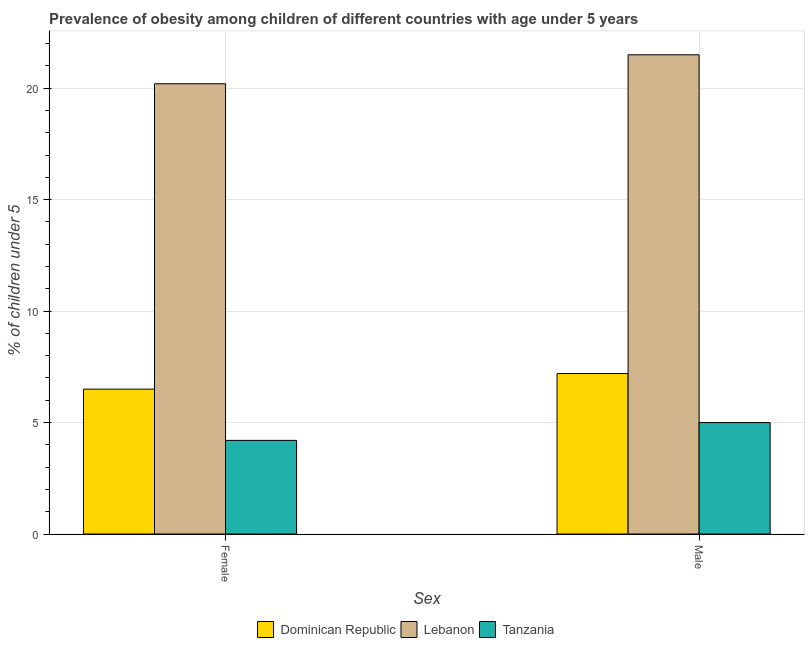How many groups of bars are there?
Keep it short and to the point. 2. Are the number of bars per tick equal to the number of legend labels?
Provide a succinct answer. Yes. How many bars are there on the 2nd tick from the left?
Offer a terse response. 3. How many bars are there on the 1st tick from the right?
Offer a terse response. 3. What is the percentage of obese male children in Tanzania?
Your answer should be compact. 5. Across all countries, what is the maximum percentage of obese female children?
Your answer should be very brief. 20.2. Across all countries, what is the minimum percentage of obese female children?
Your answer should be compact. 4.2. In which country was the percentage of obese male children maximum?
Ensure brevity in your answer.  Lebanon. In which country was the percentage of obese female children minimum?
Offer a terse response. Tanzania. What is the total percentage of obese male children in the graph?
Your response must be concise. 33.7. What is the difference between the percentage of obese female children in Tanzania and that in Lebanon?
Your answer should be very brief. -16. What is the difference between the percentage of obese male children in Tanzania and the percentage of obese female children in Lebanon?
Your answer should be very brief. -15.2. What is the average percentage of obese female children per country?
Your answer should be very brief. 10.3. What is the difference between the percentage of obese female children and percentage of obese male children in Lebanon?
Ensure brevity in your answer.  -1.3. What is the ratio of the percentage of obese male children in Tanzania to that in Dominican Republic?
Offer a terse response. 0.69. What does the 3rd bar from the left in Male represents?
Provide a short and direct response. Tanzania. What does the 3rd bar from the right in Female represents?
Give a very brief answer. Dominican Republic. How many bars are there?
Ensure brevity in your answer.  6. How many countries are there in the graph?
Make the answer very short. 3. What is the difference between two consecutive major ticks on the Y-axis?
Provide a succinct answer. 5. Does the graph contain any zero values?
Give a very brief answer. No. Where does the legend appear in the graph?
Ensure brevity in your answer.  Bottom center. How are the legend labels stacked?
Give a very brief answer. Horizontal. What is the title of the graph?
Make the answer very short. Prevalence of obesity among children of different countries with age under 5 years. Does "Guyana" appear as one of the legend labels in the graph?
Give a very brief answer. No. What is the label or title of the X-axis?
Your answer should be very brief. Sex. What is the label or title of the Y-axis?
Ensure brevity in your answer.   % of children under 5. What is the  % of children under 5 in Lebanon in Female?
Keep it short and to the point. 20.2. What is the  % of children under 5 of Tanzania in Female?
Keep it short and to the point. 4.2. What is the  % of children under 5 of Dominican Republic in Male?
Keep it short and to the point. 7.2. What is the  % of children under 5 in Lebanon in Male?
Your answer should be very brief. 21.5. Across all Sex, what is the maximum  % of children under 5 in Dominican Republic?
Give a very brief answer. 7.2. Across all Sex, what is the minimum  % of children under 5 in Dominican Republic?
Your answer should be compact. 6.5. Across all Sex, what is the minimum  % of children under 5 of Lebanon?
Keep it short and to the point. 20.2. Across all Sex, what is the minimum  % of children under 5 of Tanzania?
Your answer should be very brief. 4.2. What is the total  % of children under 5 of Lebanon in the graph?
Your answer should be very brief. 41.7. What is the difference between the  % of children under 5 of Dominican Republic in Female and that in Male?
Your response must be concise. -0.7. What is the difference between the  % of children under 5 of Lebanon in Female and that in Male?
Ensure brevity in your answer.  -1.3. What is the difference between the  % of children under 5 of Tanzania in Female and that in Male?
Offer a very short reply. -0.8. What is the difference between the  % of children under 5 of Lebanon in Female and the  % of children under 5 of Tanzania in Male?
Provide a succinct answer. 15.2. What is the average  % of children under 5 in Dominican Republic per Sex?
Provide a short and direct response. 6.85. What is the average  % of children under 5 in Lebanon per Sex?
Keep it short and to the point. 20.85. What is the average  % of children under 5 in Tanzania per Sex?
Provide a short and direct response. 4.6. What is the difference between the  % of children under 5 in Dominican Republic and  % of children under 5 in Lebanon in Female?
Make the answer very short. -13.7. What is the difference between the  % of children under 5 of Lebanon and  % of children under 5 of Tanzania in Female?
Give a very brief answer. 16. What is the difference between the  % of children under 5 of Dominican Republic and  % of children under 5 of Lebanon in Male?
Provide a short and direct response. -14.3. What is the difference between the  % of children under 5 of Lebanon and  % of children under 5 of Tanzania in Male?
Give a very brief answer. 16.5. What is the ratio of the  % of children under 5 in Dominican Republic in Female to that in Male?
Give a very brief answer. 0.9. What is the ratio of the  % of children under 5 in Lebanon in Female to that in Male?
Your answer should be compact. 0.94. What is the ratio of the  % of children under 5 of Tanzania in Female to that in Male?
Provide a short and direct response. 0.84. What is the difference between the highest and the second highest  % of children under 5 in Dominican Republic?
Give a very brief answer. 0.7. What is the difference between the highest and the second highest  % of children under 5 in Tanzania?
Your answer should be very brief. 0.8. What is the difference between the highest and the lowest  % of children under 5 of Dominican Republic?
Make the answer very short. 0.7. What is the difference between the highest and the lowest  % of children under 5 in Lebanon?
Provide a short and direct response. 1.3. What is the difference between the highest and the lowest  % of children under 5 of Tanzania?
Provide a succinct answer. 0.8. 